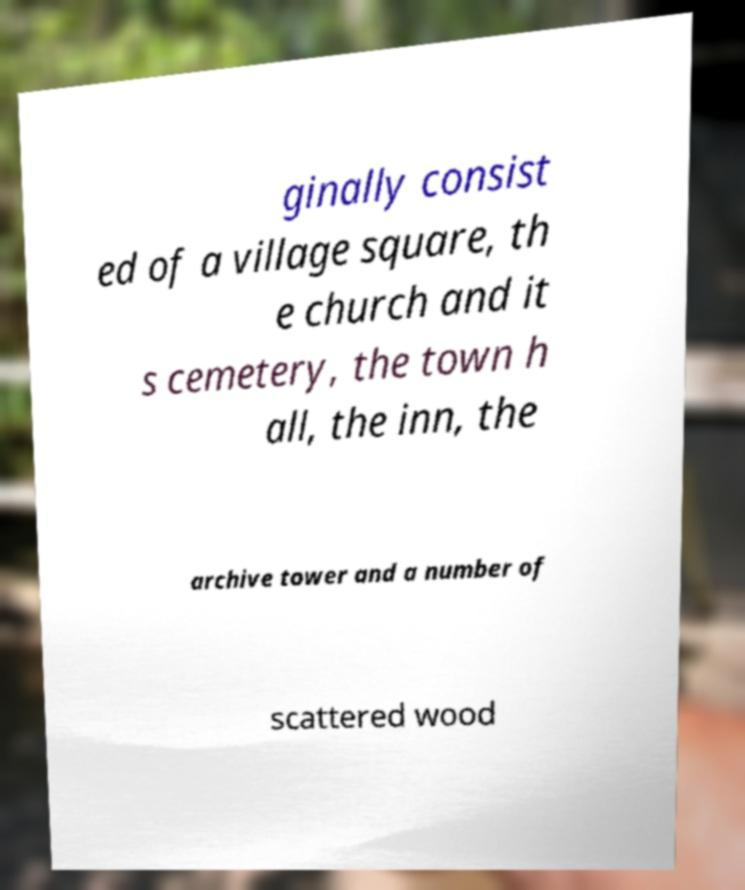There's text embedded in this image that I need extracted. Can you transcribe it verbatim? ginally consist ed of a village square, th e church and it s cemetery, the town h all, the inn, the archive tower and a number of scattered wood 